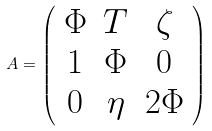Convert formula to latex. <formula><loc_0><loc_0><loc_500><loc_500>A = \left ( \begin{array} { c c c } { \Phi } & { T } & { \zeta } \\ { 1 } & { \Phi } & { 0 } \\ { 0 } & { \eta } & { 2 \Phi } \end{array} \right )</formula> 